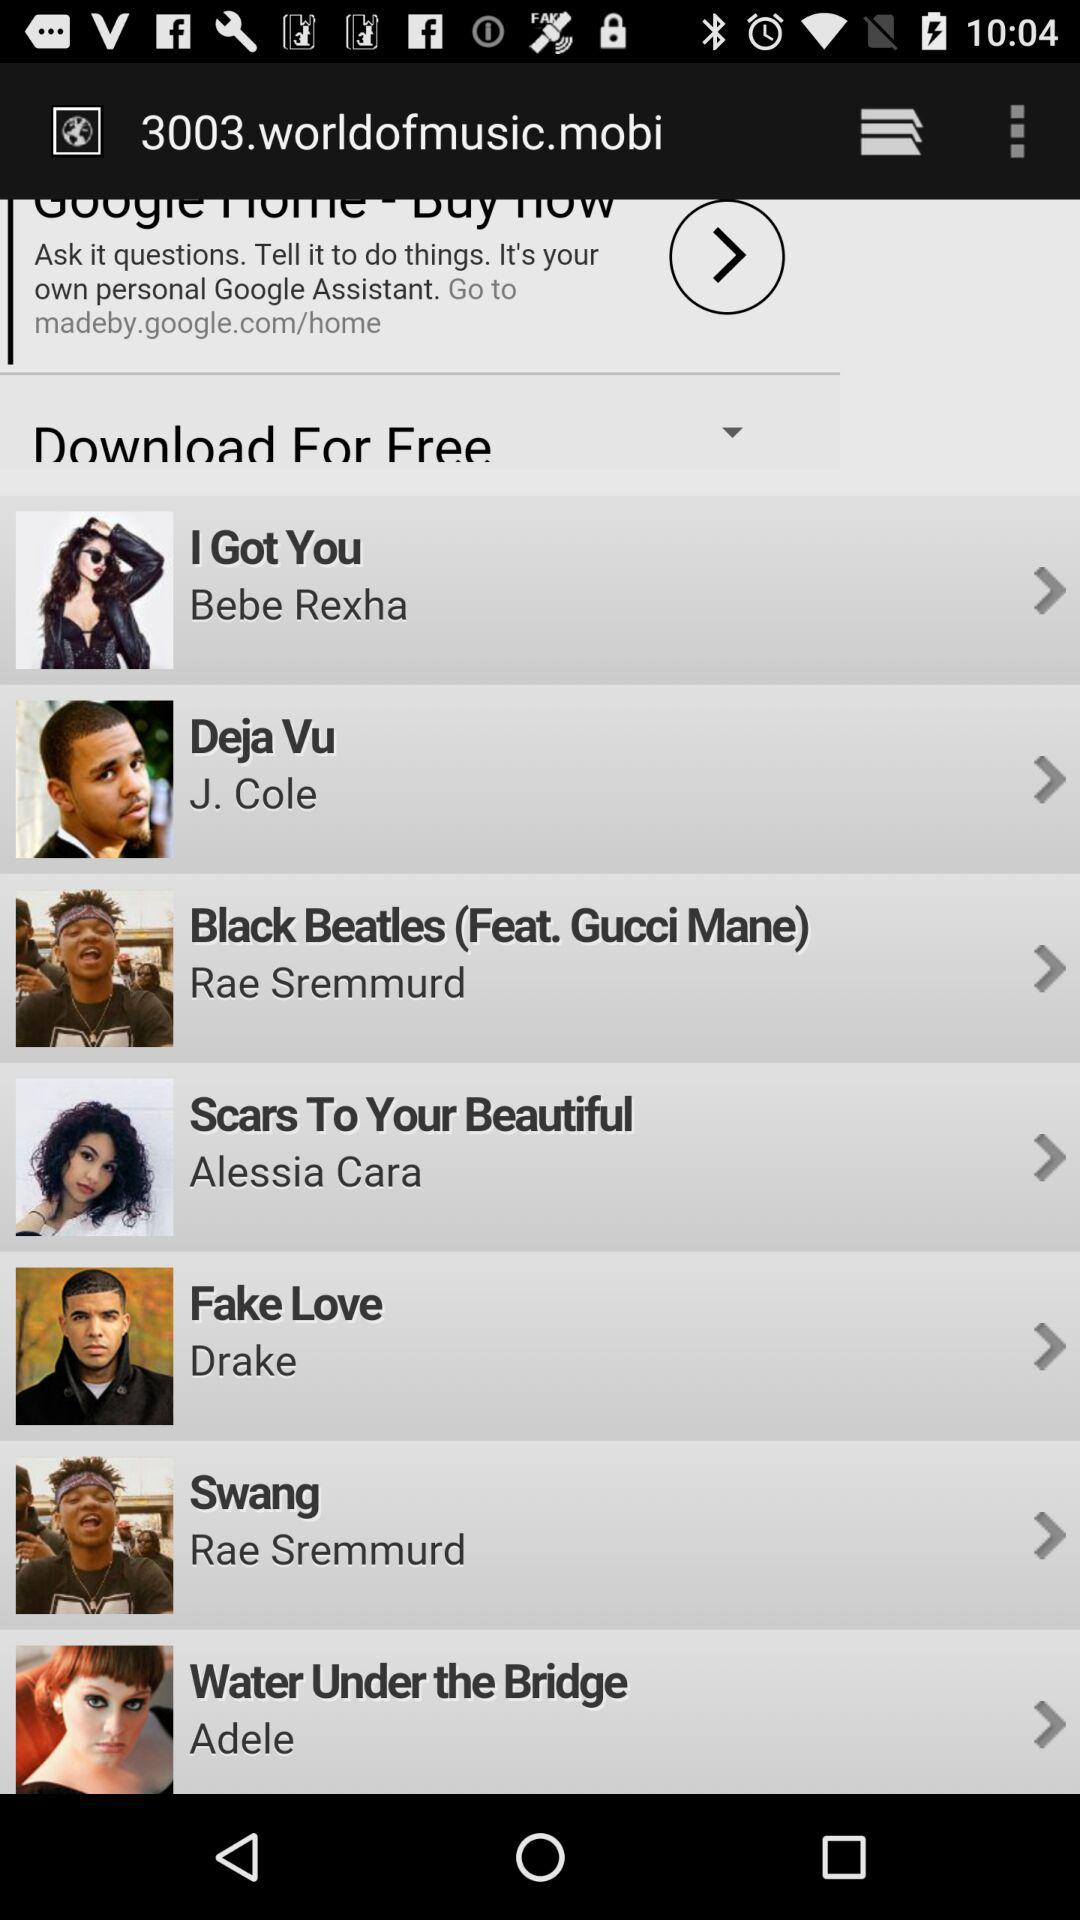How many songs are by Rae Sremmurd?
Answer the question using a single word or phrase. 2 